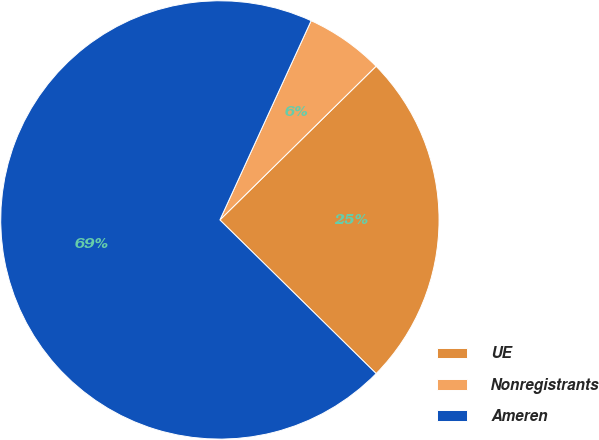Convert chart. <chart><loc_0><loc_0><loc_500><loc_500><pie_chart><fcel>UE<fcel>Nonregistrants<fcel>Ameren<nl><fcel>24.74%<fcel>5.79%<fcel>69.47%<nl></chart> 